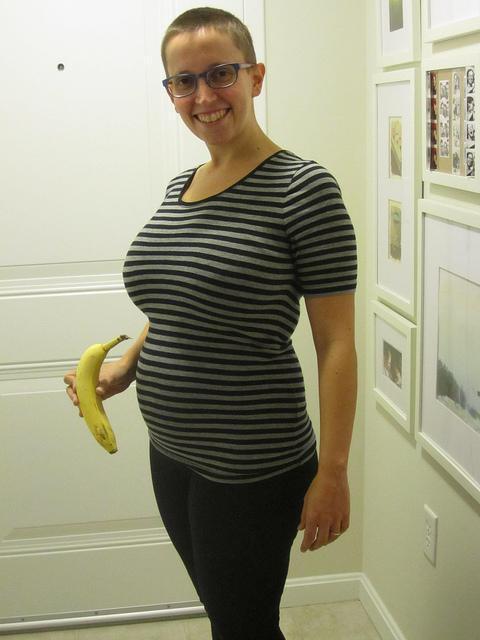Is the caption "The banana is in front of the person." a true representation of the image?
Answer yes or no. Yes. 